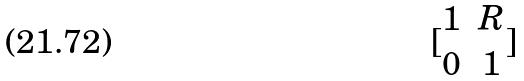Convert formula to latex. <formula><loc_0><loc_0><loc_500><loc_500>[ \begin{matrix} 1 & R \\ 0 & 1 \end{matrix} ]</formula> 